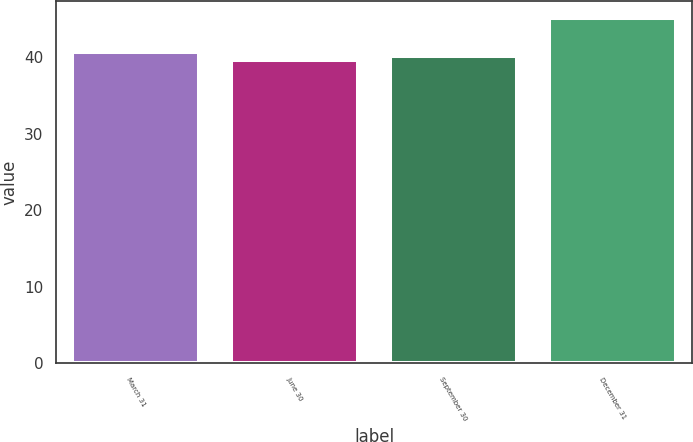Convert chart. <chart><loc_0><loc_0><loc_500><loc_500><bar_chart><fcel>March 31<fcel>June 30<fcel>September 30<fcel>December 31<nl><fcel>40.75<fcel>39.65<fcel>40.2<fcel>45.15<nl></chart> 